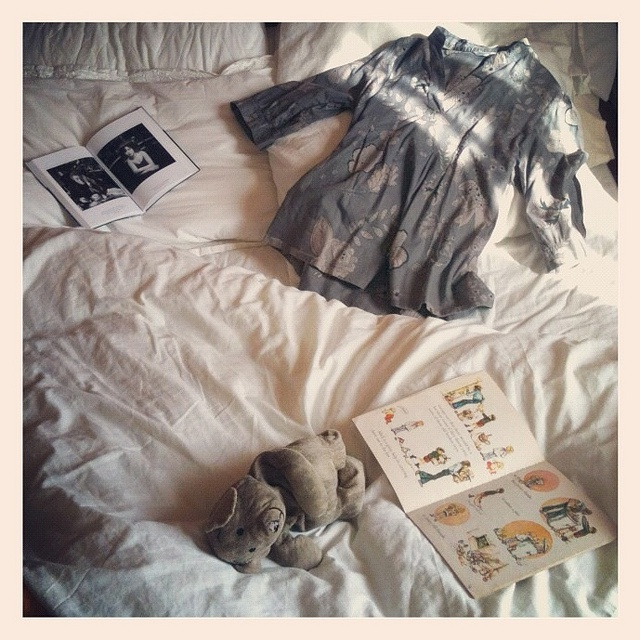Describe the objects in this image and their specific colors. I can see bed in darkgray, gray, white, lightgray, and black tones, book in white, darkgray, tan, and lightgray tones, teddy bear in white, gray, black, and darkgray tones, and book in white, black, darkgray, and gray tones in this image. 